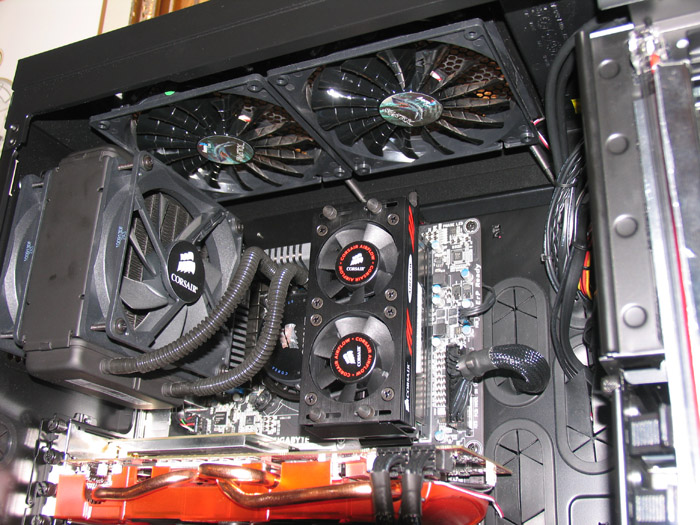What might be the future advancements in computer setups like this one in the next decade? In the next decade, computer setups like this one could undergo transformative advancements. One major development could be the integration of AI-driven optimization, where the system autonomously adjusts performance settings to maximize efficiency and minimize power consumption. Advances in quantum computing could introduce hybrid systems that leverage quantum and classical computing to handle complex calculations with unprecedented speed. Cooling technologies may evolve to include new methods such as advanced liquid metal cooling or even quantum cooling solutions to manage heat more effectively. Storage technologies would likely see significant improvements, potentially moving towards terabyte-scale NVMe SSDs with ultra-fast data transfer rates. Additionally, we might see more modular and customizable components, allowing users to easily swap out and upgrade parts without specialized knowledge. Connectivity could be enhanced with widespread adoption of ultra-fast, low-latency 5G or even 6G networks, facilitating seamless cloud integrations and real-time data processing. Overall, these advancements would create systems that are not only far more powerful but also smarter and more adaptable to the varying needs of users ranging from gamers to professionals in data-intensive fields. 